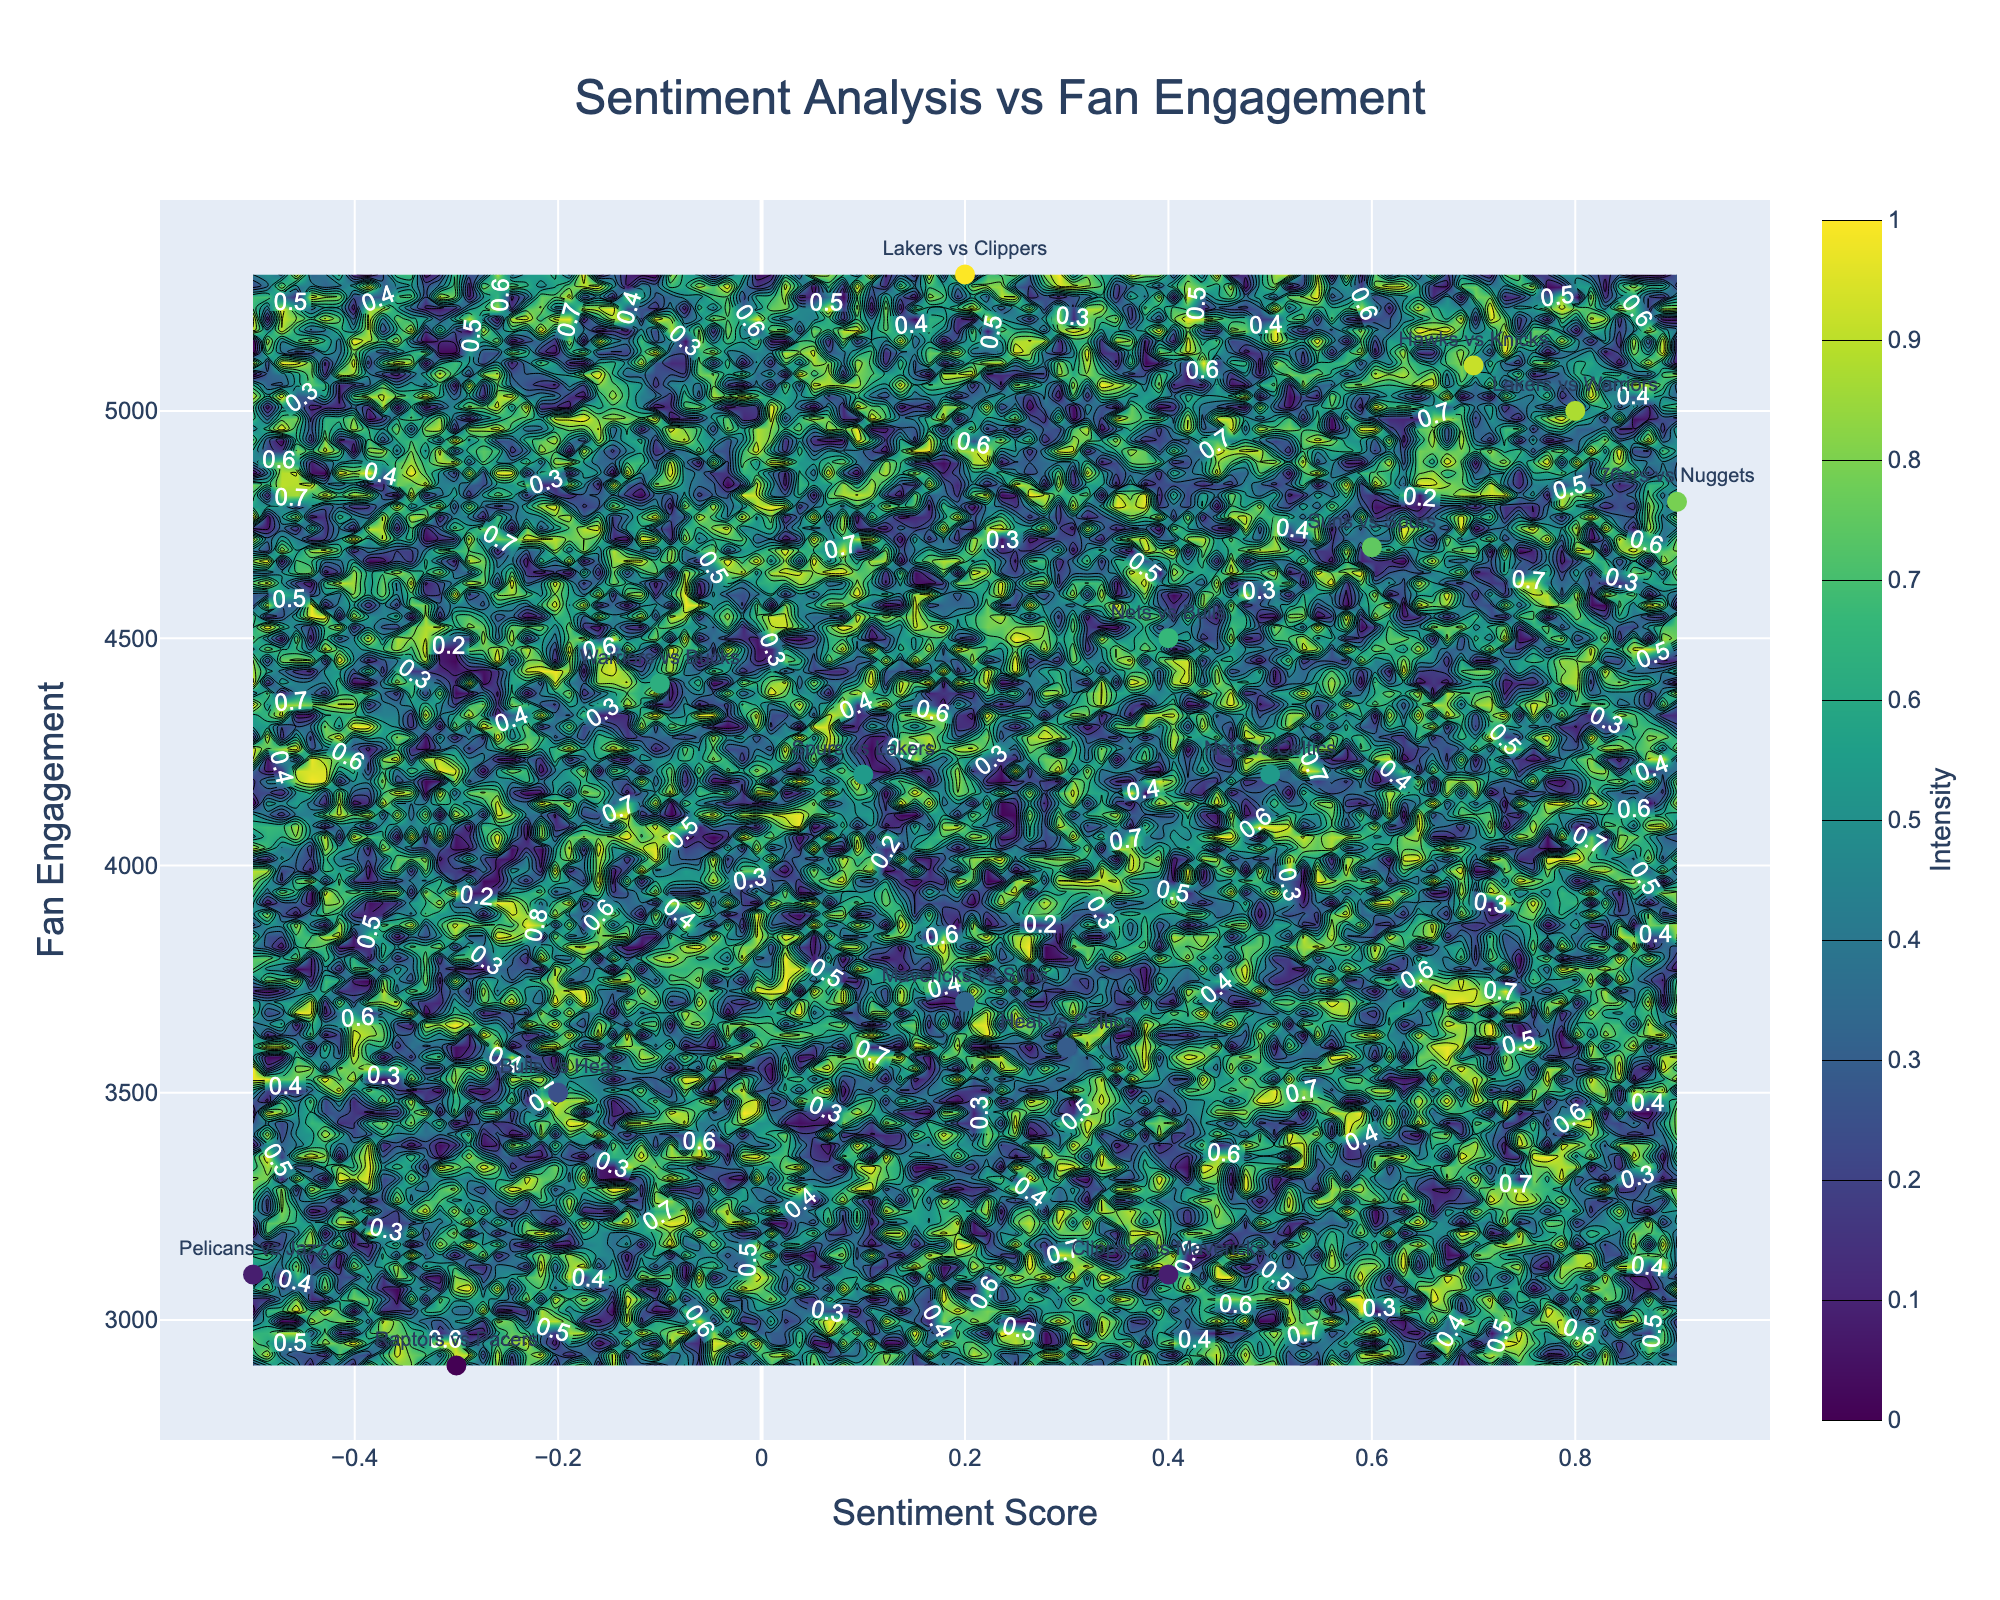what is the title of the figure? The title is typically displayed at the top of the figure. By looking at the location and larger font size, the title is easy to identify.
Answer: Sentiment Analysis vs Fan Engagement Which match has the highest fan engagement? Look for the scatter point that is highest on the y-axis, and identify the match label associated with it.
Answer: Lakers vs Clippers How many matches have a negative sentiment score? Count the number of scatter points that are to the left of the origin (0) on the x-axis.
Answer: 4 What's the average sentiment score for matches with fan engagement above 4500? Identify matches with fan engagement greater than 4500 on the y-axis, find the corresponding sentiment scores, add them, and then divide by the number of such matches. Matches: Lakers vs Warriors (0.8), Hawks vs Knicks (0.7), 76ers vs Nuggets (0.9), Lakers vs Clippers (0.2). (0.8 + 0.7 + 0.9 + 0.2) / 4 = 2.6 / 4 = 0.65
Answer: 0.65 Which match with negative sentiment has the highest fan engagement? Identify the scatter points with negative sentiment scores and find the one with the highest position on the y-axis, matching the label with it.
Answer: Warriors vs Bucks What is the range of fan engagement values? Look at the minimum and maximum values along the y-axis. The lowest and highest data points give the range of fan engagement values.
Answer: 2900 to 5300 How does fan engagement generally correlate with sentiment score? Observe the general trend of scatter points whether they form an upward, downward, or no apparent trend when moving from left to right (negative to positive sentiment scores).
Answer: Positive correlation Compare the sentiment scores of Bulls vs Heat and Heat vs Celtics. Which is higher? Locate the sentiment scores for both matches on the x-axis: Bulls vs Heat (-0.2) and Heat vs Celtics (0.3).
Answer: Heat vs Celtics Which fan engagement value is closest to the average fan engagement of all matches? Compute the average fan engagement of all matches, find the number that is closest to this average comparing each one. Averages: (5000+4200+3500+3100+4700+2900+5100+4800+5300+4400+3600+4500+3700+4200+3100)/15 = 4266.67, closest value is 4200.
Answer: Nets vs Celtics What match had the lowest sentiment score, and what was the fan engagement for that match? Locate the scatter point with the lowest value on the x-axis and note the fan engagement (y-axis) for that data point.
Answer: Pelicans vs Jazz, 3100 